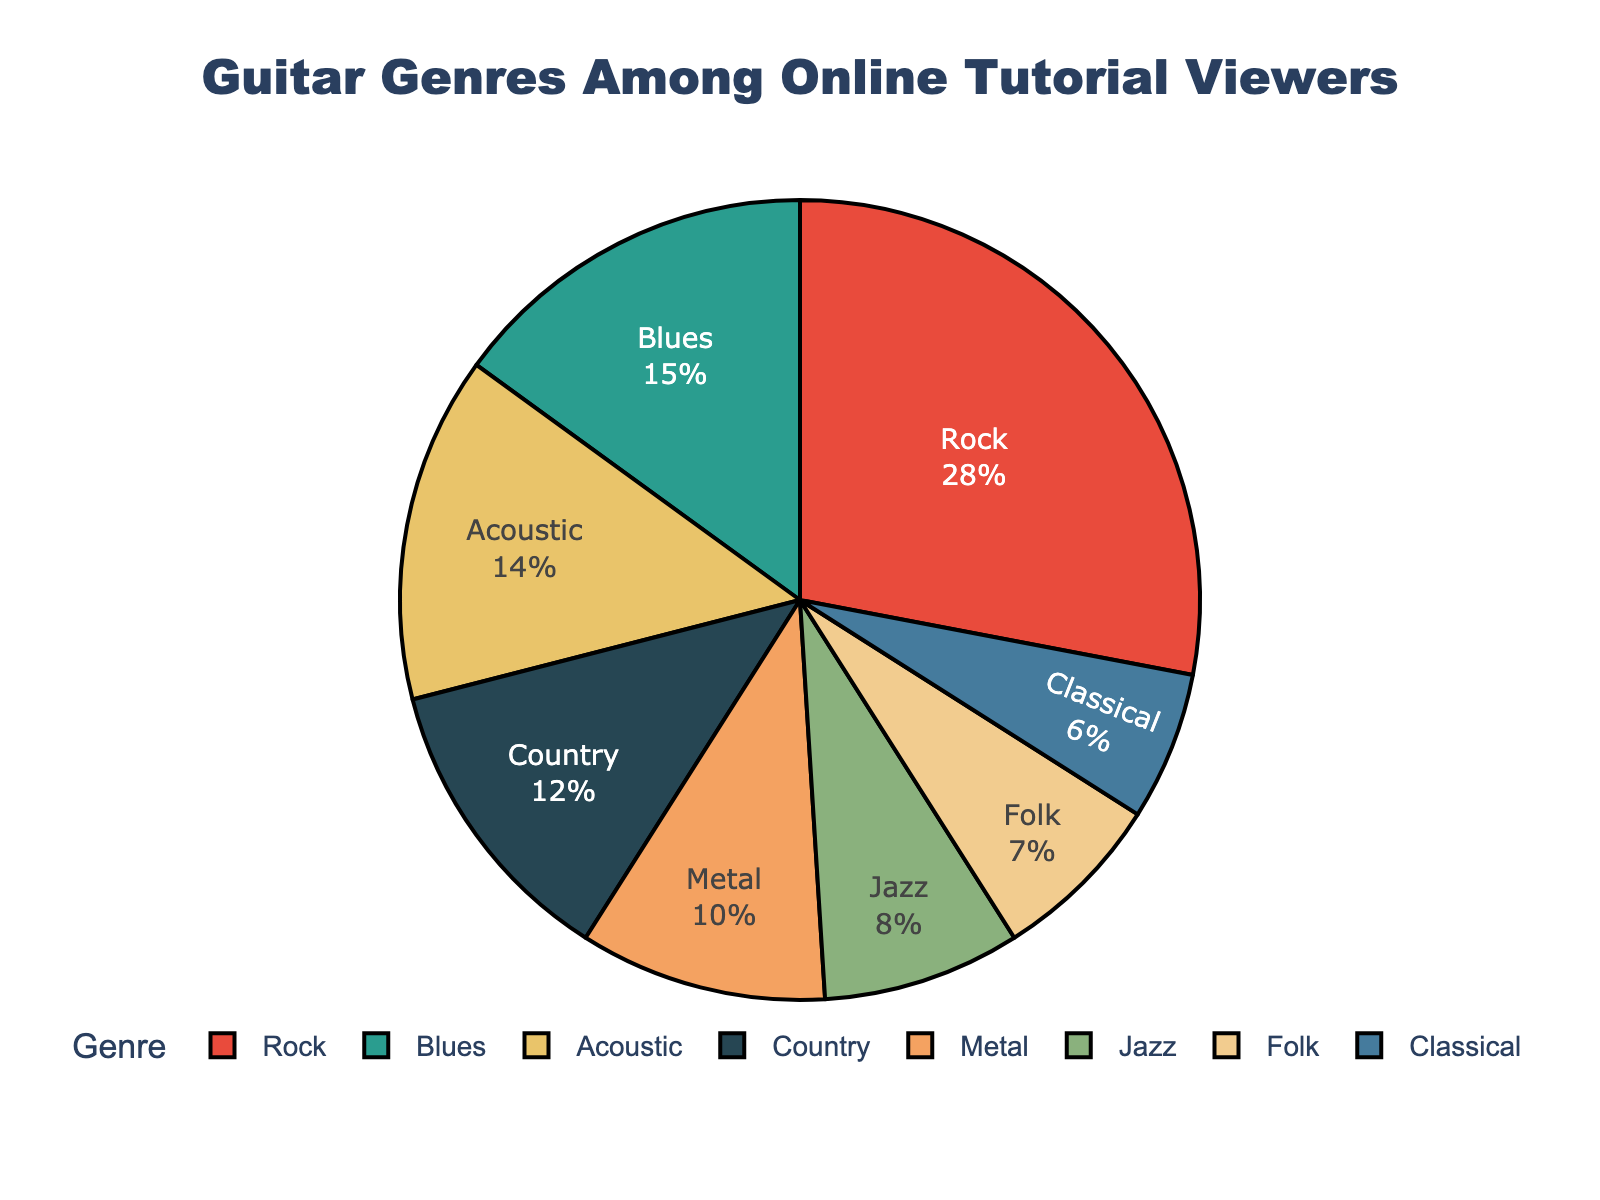What's the most popular guitar genre among online tutorial viewers? The genre with the highest percentage in the pie chart is the most popular. From the chart, Rock has 28%, which is the highest.
Answer: Rock Which genre has the smallest percentage of viewers? The genre with the smallest percentage in the pie chart is the least popular. From the chart, Classical has 6%, which is the smallest.
Answer: Classical How does the percentage of Jazz viewers compare to Metal viewers? To compare Jazz and Metal, we look at their percentages in the chart. Jazz has 8% and Metal has 10%.
Answer: Metal has a higher percentage than Jazz What's the combined percentage of Acoustic and Folk viewers? To find the combined percentage, add the percentages of Acoustic and Folk. Acoustic has 14% and Folk has 7%, so their combined percentage is 14% + 7% = 21%.
Answer: 21% What is the percentage difference between Rock and Blues viewers? To find the difference, subtract the percentage of Blues viewers from Rock viewers. Rock has 28% and Blues has 15%, so the difference is 28% - 15% = 13%.
Answer: 13% If you add the percentages of Classical, Folk, and Jazz viewers, what total percentage do you get? Add the percentages of Classical (6%), Folk (7%), and Jazz (8%). The total is 6% + 7% + 8% = 21%.
Answer: 21% Which genre is represented by the green section of the pie chart? Look at the chart and find the genre associated with the green color. According to the color palette, the green section represents Blues.
Answer: Blues Rank the following genres by their percentages from highest to lowest: Country, Metal, Acoustic, Blues. Compare the percentages of the given genres. Country has 12%, Metal has 10%, Acoustic has 14%, and Blues has 15%. The ranking from highest to lowest is Blues, Acoustic, Country, Metal.
Answer: Blues, Acoustic, Country, Metal What's the sum of the percentages of viewers for genres with percentages greater than 10%? Identify the genres with percentages greater than 10%: Rock (28%), Blues (15%), Country (12%), and Acoustic (14%). Sum these percentages: 28% + 15% + 12% + 14% = 69%.
Answer: 69% Is the percentage of viewers for Folk closer to Jazz or Classical? Compare the percentage of Folk (7%) with Jazz (8%) and Classical (6%). Folk is closer to Classical (6%) than Jazz (8%) because the difference is smaller (1% vs. 2%).
Answer: Classical 